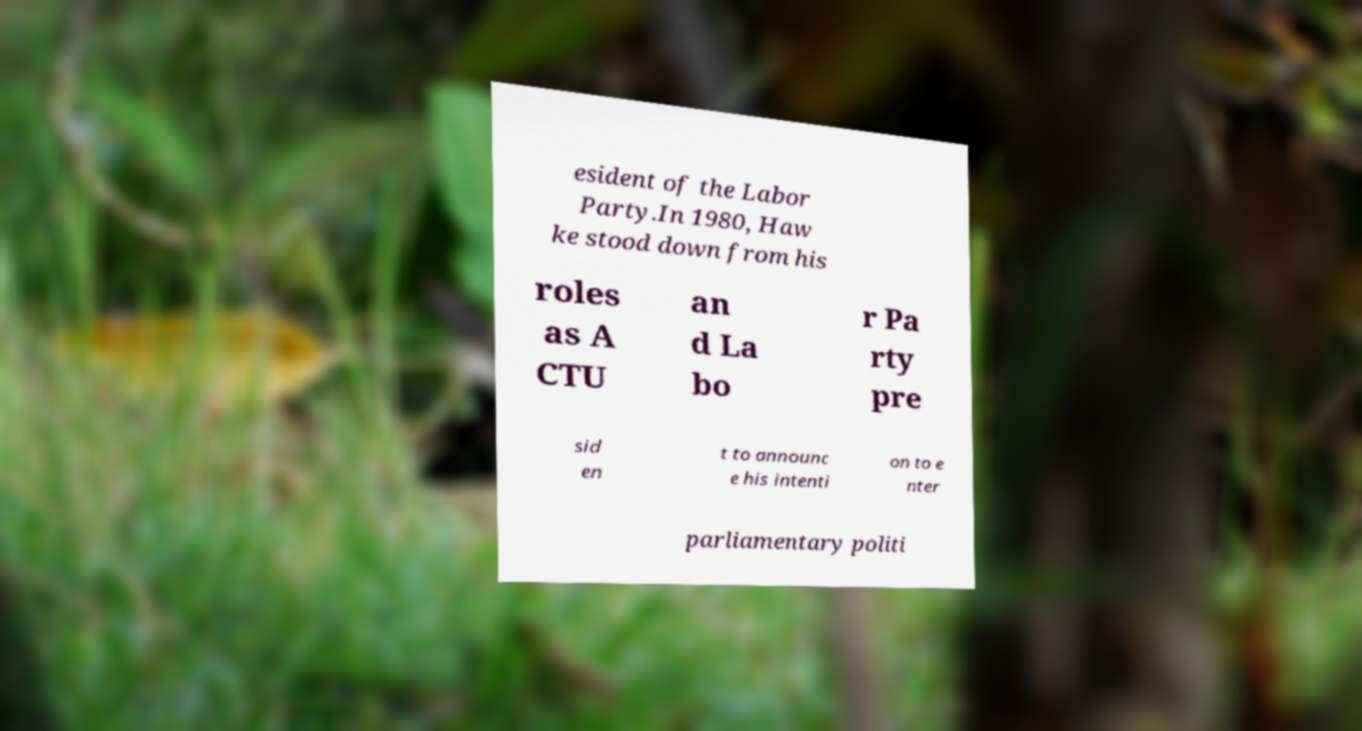Please read and relay the text visible in this image. What does it say? esident of the Labor Party.In 1980, Haw ke stood down from his roles as A CTU an d La bo r Pa rty pre sid en t to announc e his intenti on to e nter parliamentary politi 